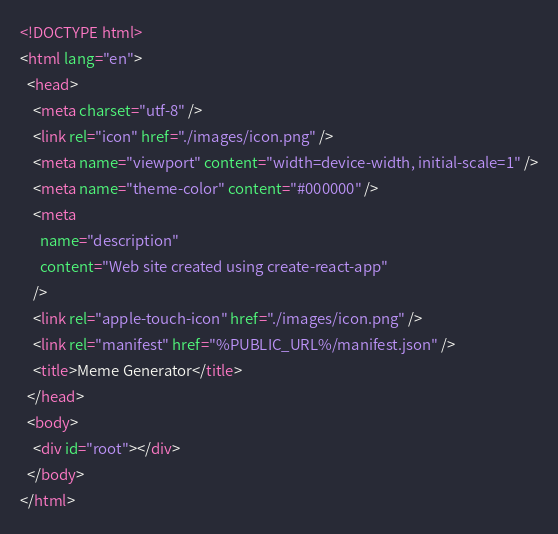Convert code to text. <code><loc_0><loc_0><loc_500><loc_500><_HTML_><!DOCTYPE html>
<html lang="en">
  <head>
    <meta charset="utf-8" />
    <link rel="icon" href="./images/icon.png" />
    <meta name="viewport" content="width=device-width, initial-scale=1" />
    <meta name="theme-color" content="#000000" />
    <meta
      name="description"
      content="Web site created using create-react-app"
    />
    <link rel="apple-touch-icon" href="./images/icon.png" />
    <link rel="manifest" href="%PUBLIC_URL%/manifest.json" />
    <title>Meme Generator</title>
  </head>
  <body>
    <div id="root"></div>
  </body>
</html>
</code> 